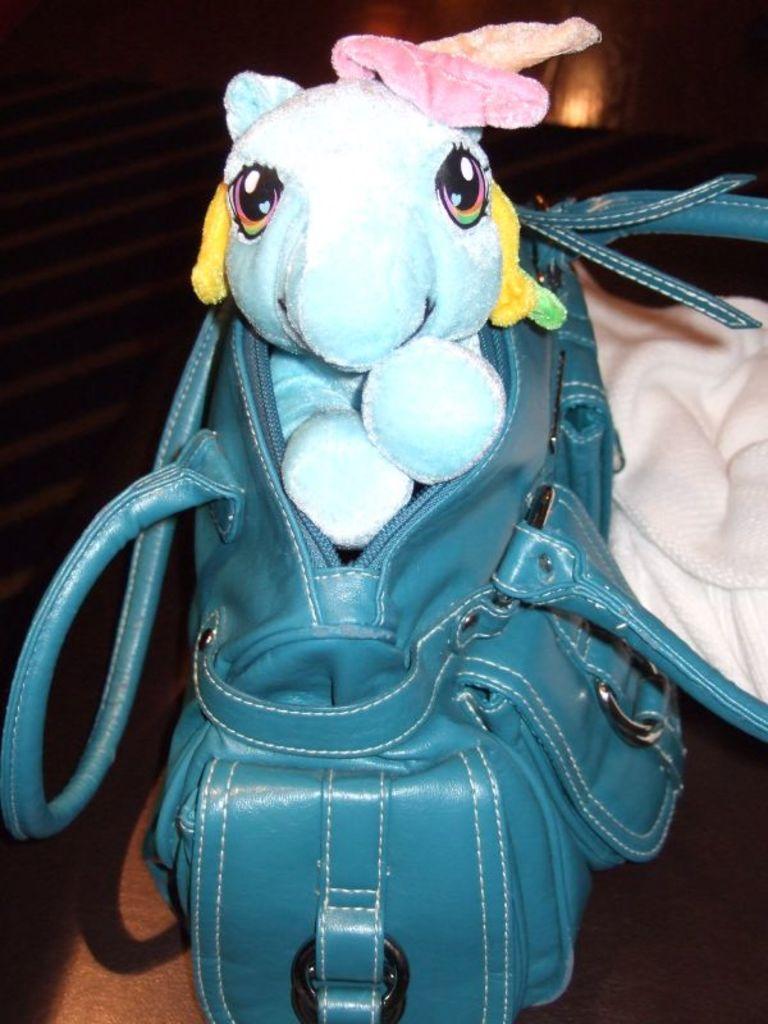Can you describe this image briefly? In this image, There is a bag of blue color in that bag there is a white color toy and there is a cream color cloth, In the background there is brown color stairs. 